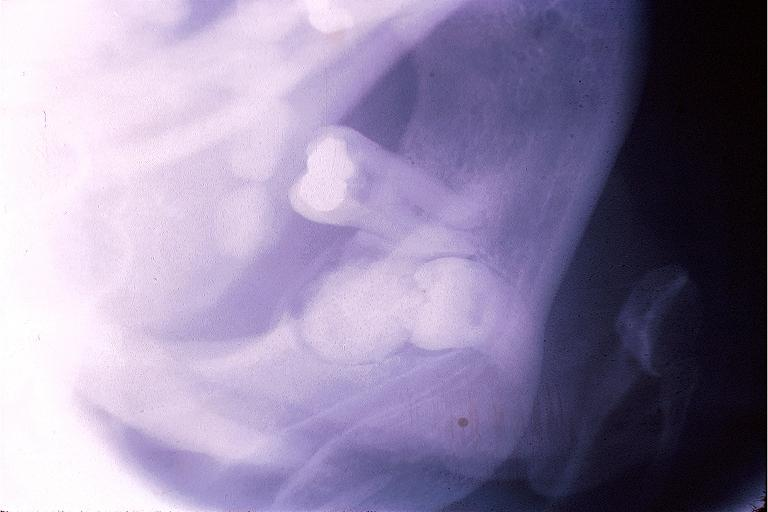s the superior vena cava present?
Answer the question using a single word or phrase. No 